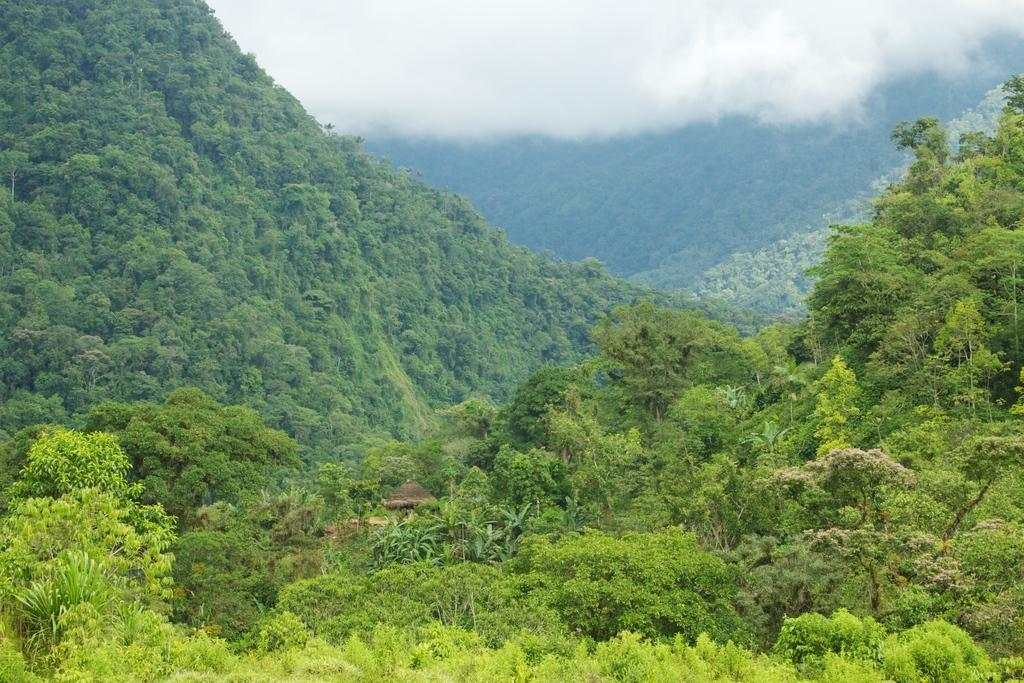What is the main structure in the center of the image? There is a hut in the center of the image. What type of natural elements can be seen in the image? There are trees and mountains in the image. What part of the environment is visible in the image? The sky is visible in the image. How many frogs are sitting on the coat in the image? There are no frogs or coats present in the image. 